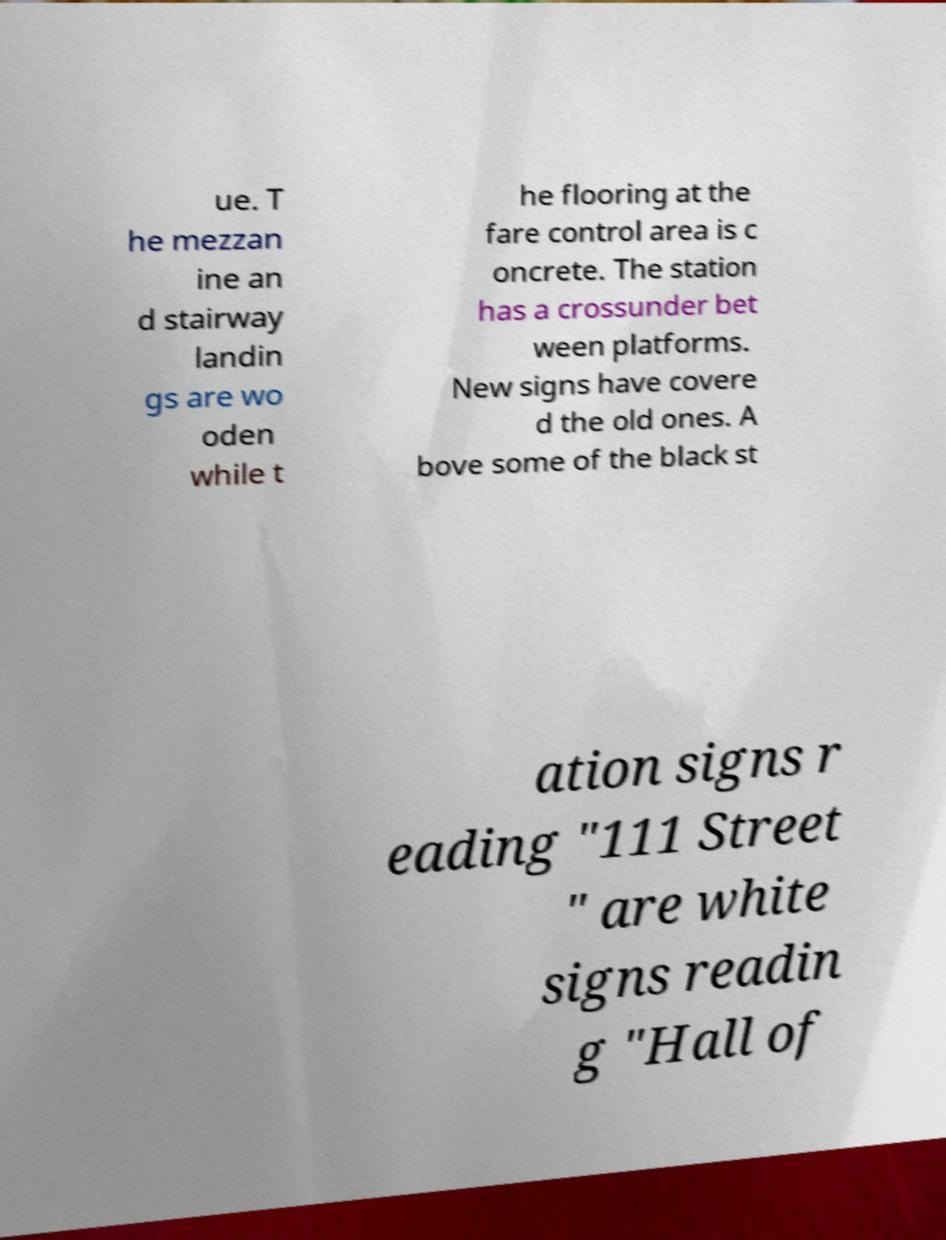Can you read and provide the text displayed in the image?This photo seems to have some interesting text. Can you extract and type it out for me? ue. T he mezzan ine an d stairway landin gs are wo oden while t he flooring at the fare control area is c oncrete. The station has a crossunder bet ween platforms. New signs have covere d the old ones. A bove some of the black st ation signs r eading "111 Street " are white signs readin g "Hall of 